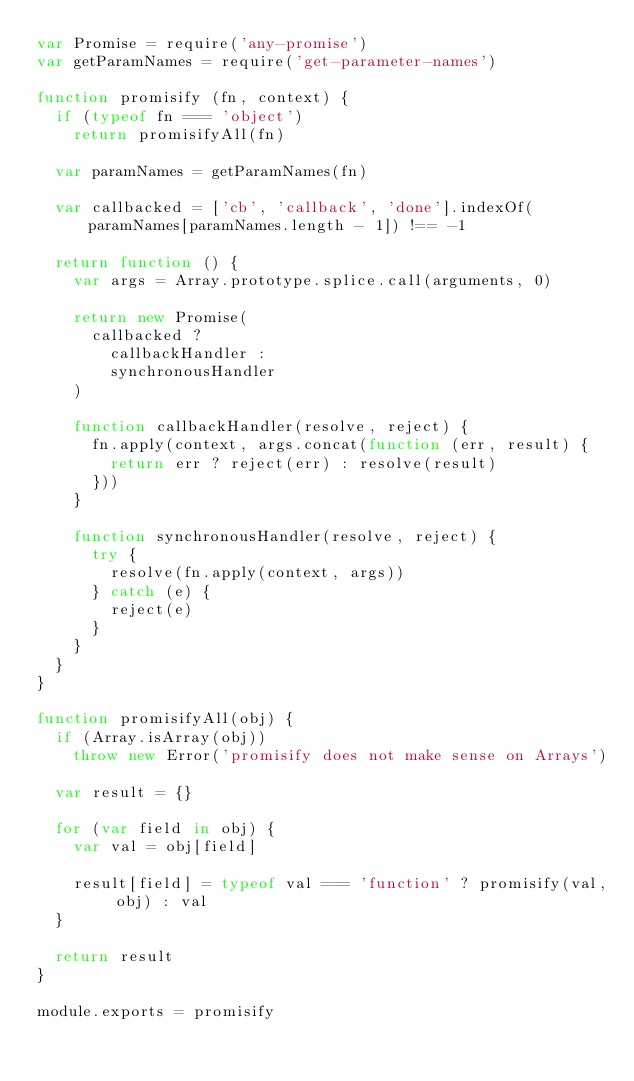<code> <loc_0><loc_0><loc_500><loc_500><_JavaScript_>var Promise = require('any-promise')
var getParamNames = require('get-parameter-names')

function promisify (fn, context) {
  if (typeof fn === 'object')
    return promisifyAll(fn)

  var paramNames = getParamNames(fn)

  var callbacked = ['cb', 'callback', 'done'].indexOf(paramNames[paramNames.length - 1]) !== -1

  return function () {
    var args = Array.prototype.splice.call(arguments, 0)

    return new Promise(
      callbacked ?
        callbackHandler :
        synchronousHandler
    )

    function callbackHandler(resolve, reject) {
      fn.apply(context, args.concat(function (err, result) {
        return err ? reject(err) : resolve(result)
      }))
    }

    function synchronousHandler(resolve, reject) {
      try {
        resolve(fn.apply(context, args))
      } catch (e) {
        reject(e)
      }
    }
  }
}

function promisifyAll(obj) {
  if (Array.isArray(obj))
    throw new Error('promisify does not make sense on Arrays')

  var result = {}

  for (var field in obj) {
    var val = obj[field]

    result[field] = typeof val === 'function' ? promisify(val, obj) : val
  }

  return result
}

module.exports = promisify
</code> 